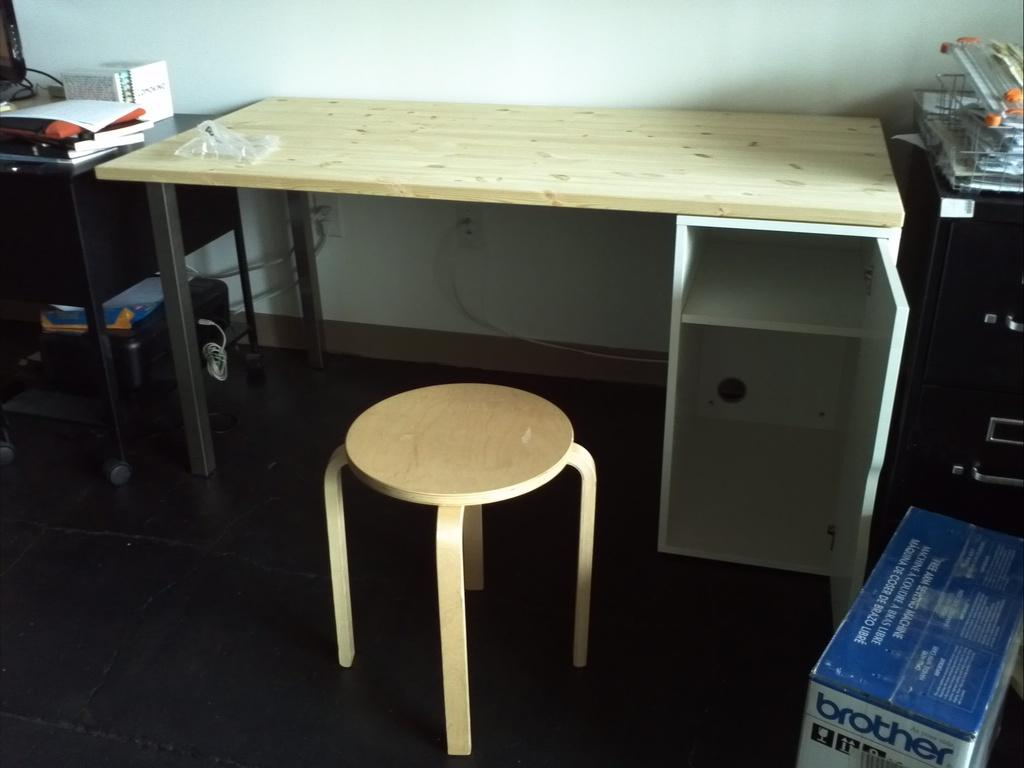<image>
Relay a brief, clear account of the picture shown. Desk with a stool and brother printer with a blue up. 